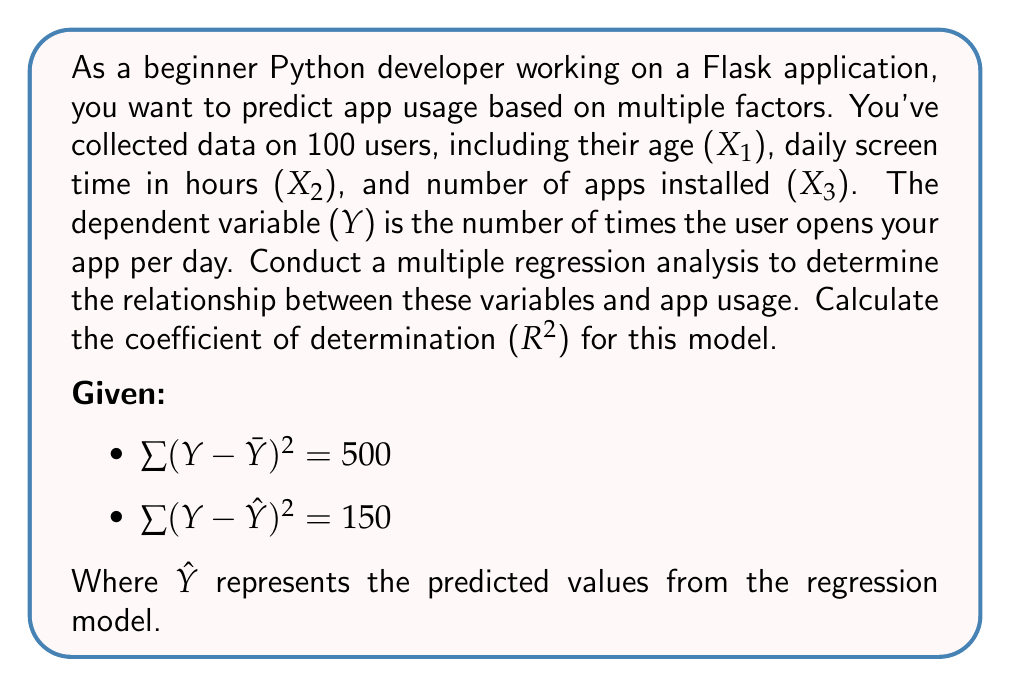Teach me how to tackle this problem. To conduct a multiple regression analysis and calculate the coefficient of determination (R-squared), we'll follow these steps:

1. Understand the variables:
   - Dependent variable (Y): Number of times the user opens the app per day
   - Independent variables: 
     - X1: Age
     - X2: Daily screen time in hours
     - X3: Number of apps installed

2. The multiple regression model takes the form:
   $$Y = \beta_0 + \beta_1X_1 + \beta_2X_2 + \beta_3X_3 + \epsilon$$

   Where $\beta_0$ is the intercept, $\beta_1$, $\beta_2$, and $\beta_3$ are the coefficients for each independent variable, and $\epsilon$ is the error term.

3. To calculate R-squared, we use the formula:
   $$R^2 = 1 - \frac{SSE}{SST}$$

   Where:
   - SSE (Sum of Squared Errors) = $\sum (Y - \hat{Y})^2$
   - SST (Total Sum of Squares) = $\sum (Y - \bar{Y})^2$

4. Using the given information:
   - SST = $\sum (Y - \bar{Y})^2 = 500$
   - SSE = $\sum (Y - \hat{Y})^2 = 150$

5. Calculate R-squared:
   $$R^2 = 1 - \frac{SSE}{SST} = 1 - \frac{150}{500} = 1 - 0.3 = 0.7$$

6. Interpret the result:
   The R-squared value of 0.7 indicates that 70% of the variance in app usage (Y) can be explained by the independent variables (age, daily screen time, and number of apps installed) in our multiple regression model.
Answer: R-squared = 0.7 